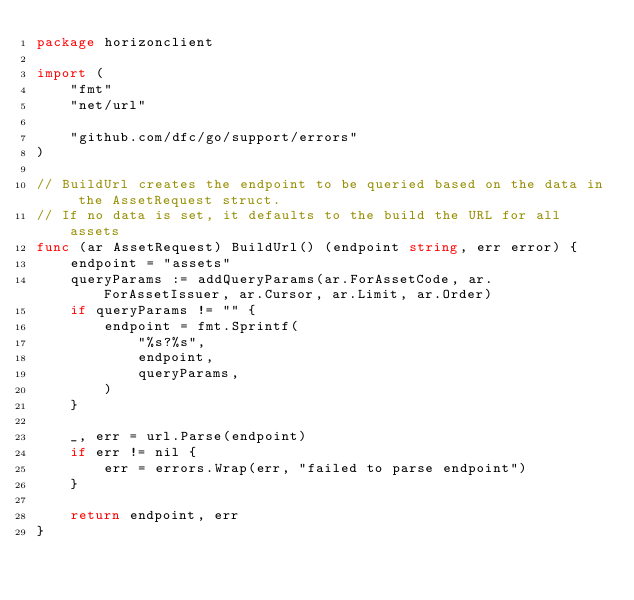<code> <loc_0><loc_0><loc_500><loc_500><_Go_>package horizonclient

import (
	"fmt"
	"net/url"

	"github.com/dfc/go/support/errors"
)

// BuildUrl creates the endpoint to be queried based on the data in the AssetRequest struct.
// If no data is set, it defaults to the build the URL for all assets
func (ar AssetRequest) BuildUrl() (endpoint string, err error) {
	endpoint = "assets"
	queryParams := addQueryParams(ar.ForAssetCode, ar.ForAssetIssuer, ar.Cursor, ar.Limit, ar.Order)
	if queryParams != "" {
		endpoint = fmt.Sprintf(
			"%s?%s",
			endpoint,
			queryParams,
		)
	}

	_, err = url.Parse(endpoint)
	if err != nil {
		err = errors.Wrap(err, "failed to parse endpoint")
	}

	return endpoint, err
}
</code> 